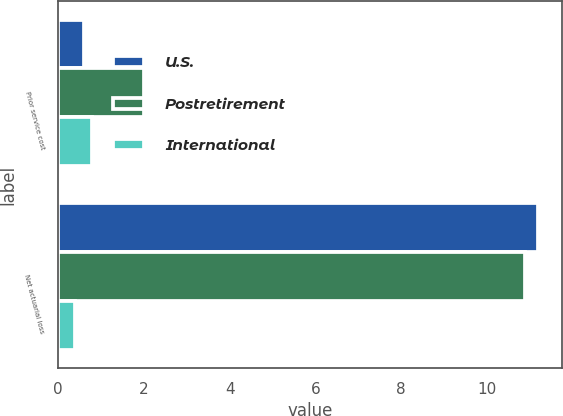Convert chart to OTSL. <chart><loc_0><loc_0><loc_500><loc_500><stacked_bar_chart><ecel><fcel>Prior service cost<fcel>Net actuarial loss<nl><fcel>U.S.<fcel>0.6<fcel>11.2<nl><fcel>Postretirement<fcel>2<fcel>10.9<nl><fcel>International<fcel>0.8<fcel>0.4<nl></chart> 